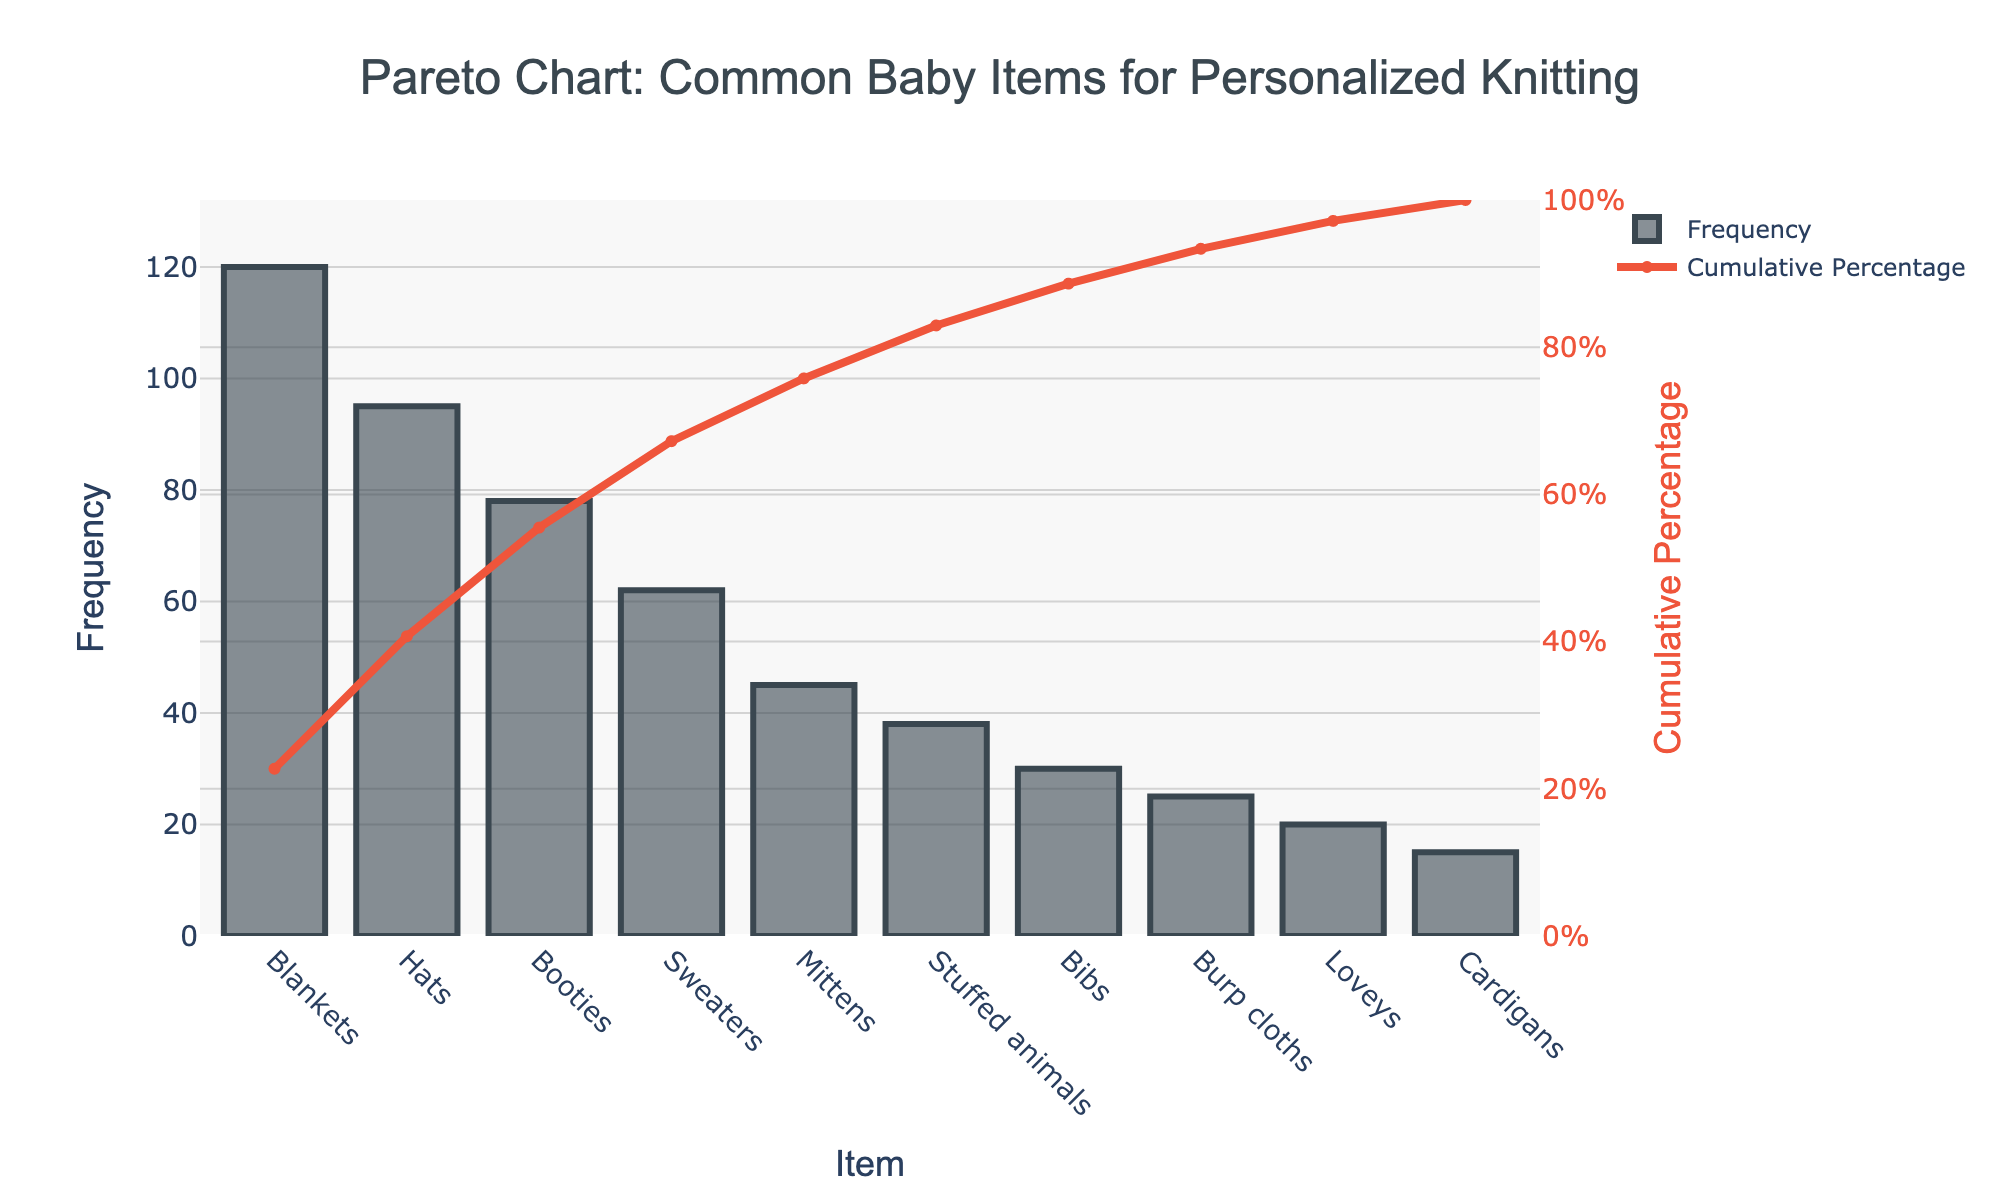What's the most frequently requested baby item for personalized knitting? The title and x-axis of the chart show a bar labeled "Blankets" with the highest frequency value.
Answer: Blankets What's the cumulative percentage for Hats? Locate Hats on the x-axis and find its corresponding point on the cumulative percentage line, which is approximately 43%.
Answer: 43% How many items have a cumulative percentage over 75%? Look at where the cumulative percentage line crosses 75%, and count the number of items before that point. These items are Blankets, Hats, Booties, Sweaters, and Mittens.
Answer: 5 items Which item has a frequency between 30 and 45 and what is its cumulative percentage? Identify the item with a frequency in this range. Mittens fit this criterion. Check the cumulative percentage line at this point, which is about 70%.
Answer: Mittens, 70% What's the difference in frequency between the most and least requested items? The most requested item is Blankets with 120, and the least requested is Cardigans with 15. The difference is 120 - 15.
Answer: 105 Which item comes after Booties in frequency ranking and what’s its cumulative percentage? Booties are third, followed by Sweaters with a frequency of 62, and its cumulative percentage is about 68%.
Answer: Sweaters, 68% Which two items together contribute just under 40% of the total requests? Check the items on the x-axis and their cumulative percentages. Hats and Booties together contribute around 37%.
Answer: Hats and Booties What percentage of items is contributed by the top three requested types? Identify the top three items (Blankets, Hats, Booties), and sum their cumulative percentages: approximately 37% + 80%.
Answer: 80% Which item has a frequency of 38 and what’s its rank? Locate the item labeled Stuffed animals with a frequency of 38. It is the sixth item in frequency.
Answer: Stuffed animals, 6th What's the cumulative percentage increase from Loveys to Burp cloths? Identify the cumulative percentages: Loveys are around 91% and Burp cloths are around 87%, the difference is 91% - 87%.
Answer: 4% 